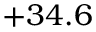<formula> <loc_0><loc_0><loc_500><loc_500>+ 3 4 . 6</formula> 